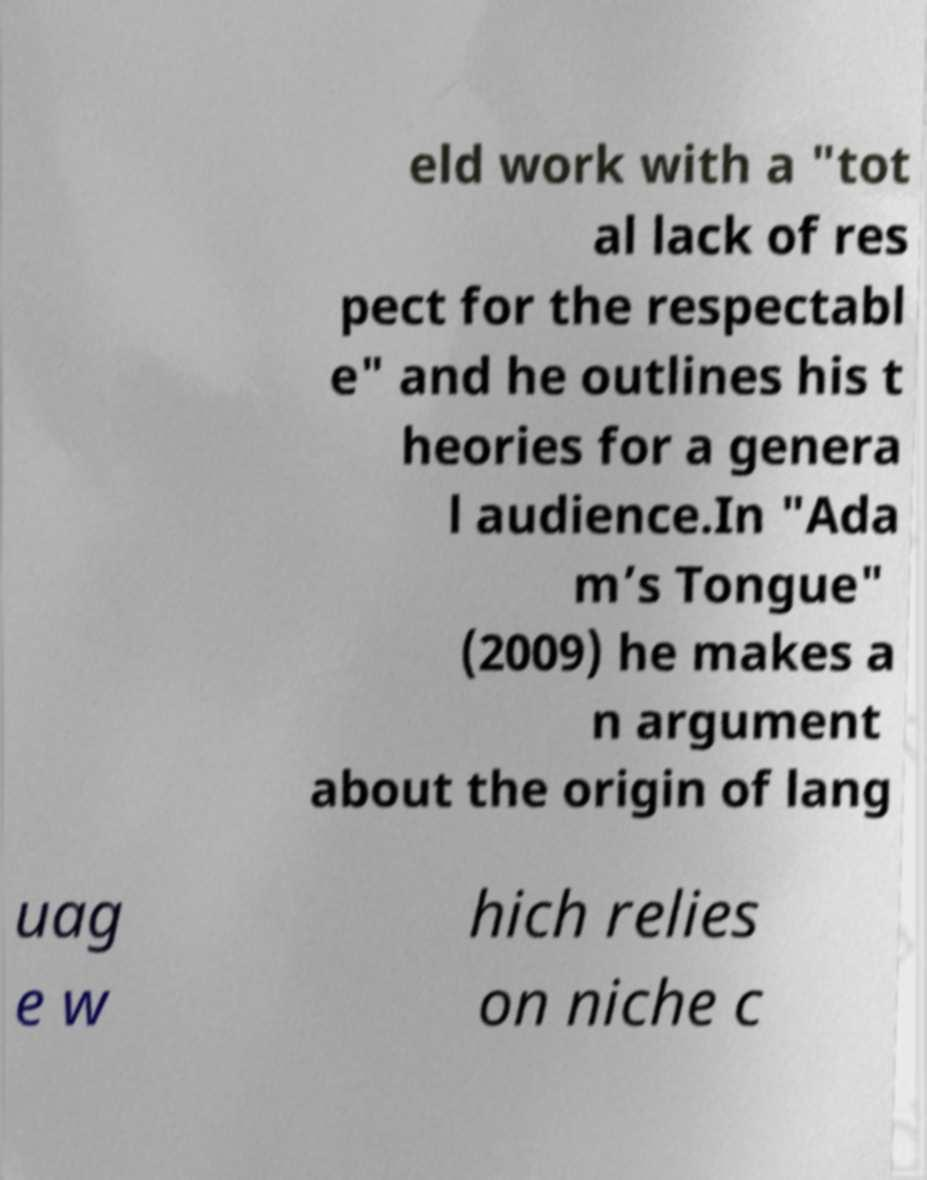Please identify and transcribe the text found in this image. eld work with a "tot al lack of res pect for the respectabl e" and he outlines his t heories for a genera l audience.In "Ada m’s Tongue" (2009) he makes a n argument about the origin of lang uag e w hich relies on niche c 